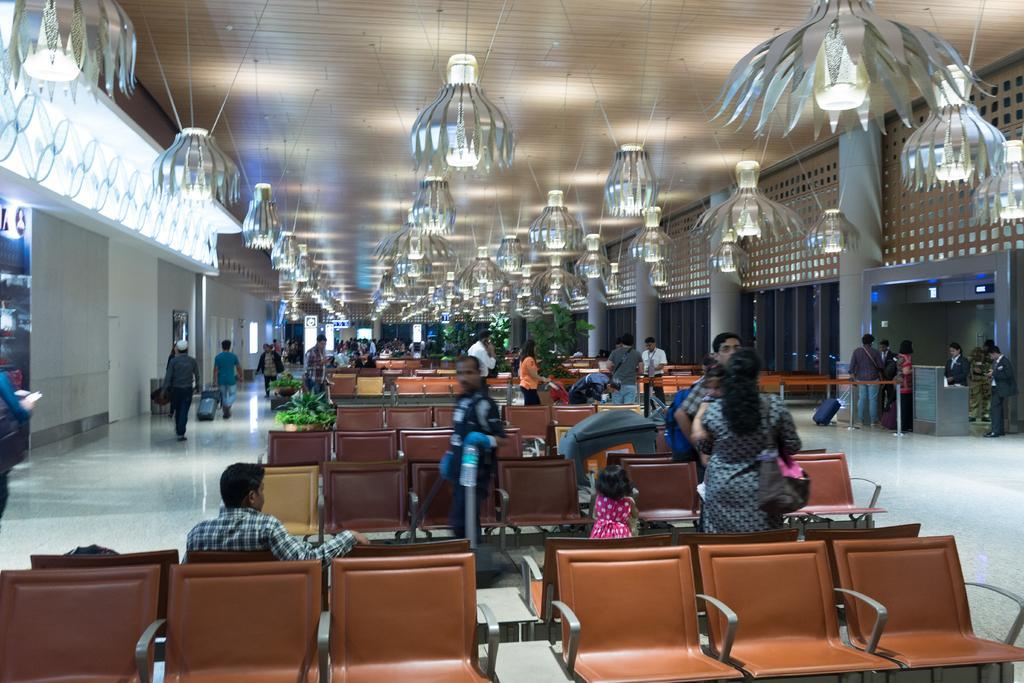Can you describe this image briefly? In the picture I can see people are standing on the ground. I can also see some of them are sitting on chairs. In the background I can see walls, chandeliers, pillars, chairs, ceiling and some other object on the floor. 